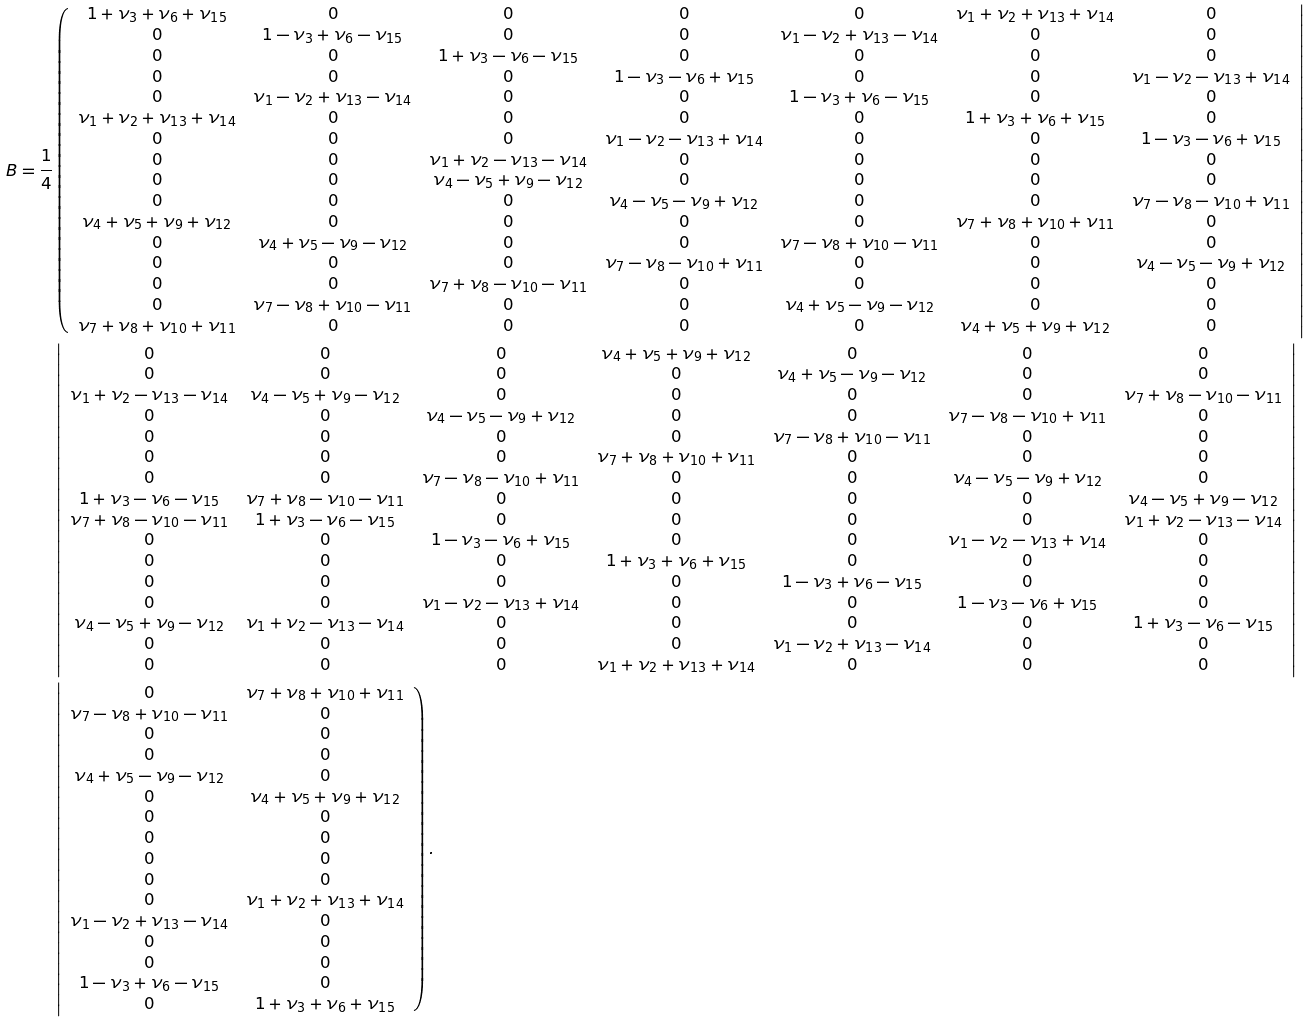<formula> <loc_0><loc_0><loc_500><loc_500>B = \frac { 1 } { 4 } & \left ( \begin{array} { c c c c c c c } 1 + \nu _ { 3 } + \nu _ { 6 } + \nu _ { 1 5 } & 0 & 0 & 0 & 0 & \nu _ { 1 } + \nu _ { 2 } + \nu _ { 1 3 } + \nu _ { 1 4 } & 0 \\ 0 & 1 - \nu _ { 3 } + \nu _ { 6 } - \nu _ { 1 5 } & 0 & 0 & \nu _ { 1 } - \nu _ { 2 } + \nu _ { 1 3 } - \nu _ { 1 4 } & 0 & 0 \\ 0 & 0 & 1 + \nu _ { 3 } - \nu _ { 6 } - \nu _ { 1 5 } & 0 & 0 & 0 & 0 \\ 0 & 0 & 0 & 1 - \nu _ { 3 } - \nu _ { 6 } + \nu _ { 1 5 } & 0 & 0 & \nu _ { 1 } - \nu _ { 2 } - \nu _ { 1 3 } + \nu _ { 1 4 } \\ 0 & \nu _ { 1 } - \nu _ { 2 } + \nu _ { 1 3 } - \nu _ { 1 4 } & 0 & 0 & 1 - \nu _ { 3 } + \nu _ { 6 } - \nu _ { 1 5 } & 0 & 0 \\ \nu _ { 1 } + \nu _ { 2 } + \nu _ { 1 3 } + \nu _ { 1 4 } & 0 & 0 & 0 & 0 & 1 + \nu _ { 3 } + \nu _ { 6 } + \nu _ { 1 5 } & 0 \\ 0 & 0 & 0 & \nu _ { 1 } - \nu _ { 2 } - \nu _ { 1 3 } + \nu _ { 1 4 } & 0 & 0 & 1 - \nu _ { 3 } - \nu _ { 6 } + \nu _ { 1 5 } \\ 0 & 0 & \nu _ { 1 } + \nu _ { 2 } - \nu _ { 1 3 } - \nu _ { 1 4 } & 0 & 0 & 0 & 0 \\ 0 & 0 & \nu _ { 4 } - \nu _ { 5 } + \nu _ { 9 } - \nu _ { 1 2 } & 0 & 0 & 0 & 0 \\ 0 & 0 & 0 & \nu _ { 4 } - \nu _ { 5 } - \nu _ { 9 } + \nu _ { 1 2 } & 0 & 0 & \nu _ { 7 } - \nu _ { 8 } - \nu _ { 1 0 } + \nu _ { 1 1 } \\ \nu _ { 4 } + \nu _ { 5 } + \nu _ { 9 } + \nu _ { 1 2 } & 0 & 0 & 0 & 0 & \nu _ { 7 } + \nu _ { 8 } + \nu _ { 1 0 } + \nu _ { 1 1 } & 0 \\ 0 & \nu _ { 4 } + \nu _ { 5 } - \nu _ { 9 } - \nu _ { 1 2 } & 0 & 0 & \nu _ { 7 } - \nu _ { 8 } + \nu _ { 1 0 } - \nu _ { 1 1 } & 0 & 0 \\ 0 & 0 & 0 & \nu _ { 7 } - \nu _ { 8 } - \nu _ { 1 0 } + \nu _ { 1 1 } & 0 & 0 & \nu _ { 4 } - \nu _ { 5 } - \nu _ { 9 } + \nu _ { 1 2 } \\ 0 & 0 & \nu _ { 7 } + \nu _ { 8 } - \nu _ { 1 0 } - \nu _ { 1 1 } & 0 & 0 & 0 & 0 \\ 0 & \nu _ { 7 } - \nu _ { 8 } + \nu _ { 1 0 } - \nu _ { 1 1 } & 0 & 0 & \nu _ { 4 } + \nu _ { 5 } - \nu _ { 9 } - \nu _ { 1 2 } & 0 & 0 \\ \nu _ { 7 } + \nu _ { 8 } + \nu _ { 1 0 } + \nu _ { 1 1 } & 0 & 0 & 0 & 0 & \nu _ { 4 } + \nu _ { 5 } + \nu _ { 9 } + \nu _ { 1 2 } & 0 \end{array} \right | \\ & \left | \begin{array} { c c c c c c c } 0 & 0 & 0 & \nu _ { 4 } + \nu _ { 5 } + \nu _ { 9 } + \nu _ { 1 2 } & 0 & 0 & 0 \\ 0 & 0 & 0 & 0 & \nu _ { 4 } + \nu _ { 5 } - \nu _ { 9 } - \nu _ { 1 2 } & 0 & 0 \\ \nu _ { 1 } + \nu _ { 2 } - \nu _ { 1 3 } - \nu _ { 1 4 } & \nu _ { 4 } - \nu _ { 5 } + \nu _ { 9 } - \nu _ { 1 2 } & 0 & 0 & 0 & 0 & \nu _ { 7 } + \nu _ { 8 } - \nu _ { 1 0 } - \nu _ { 1 1 } \\ 0 & 0 & \nu _ { 4 } - \nu _ { 5 } - \nu _ { 9 } + \nu _ { 1 2 } & 0 & 0 & \nu _ { 7 } - \nu _ { 8 } - \nu _ { 1 0 } + \nu _ { 1 1 } & 0 \\ 0 & 0 & 0 & 0 & \nu _ { 7 } - \nu _ { 8 } + \nu _ { 1 0 } - \nu _ { 1 1 } & 0 & 0 \\ 0 & 0 & 0 & \nu _ { 7 } + \nu _ { 8 } + \nu _ { 1 0 } + \nu _ { 1 1 } & 0 & 0 & 0 \\ 0 & 0 & \nu _ { 7 } - \nu _ { 8 } - \nu _ { 1 0 } + \nu _ { 1 1 } & 0 & 0 & \nu _ { 4 } - \nu _ { 5 } - \nu _ { 9 } + \nu _ { 1 2 } & 0 \\ 1 + \nu _ { 3 } - \nu _ { 6 } - \nu _ { 1 5 } & \nu _ { 7 } + \nu _ { 8 } - \nu _ { 1 0 } - \nu _ { 1 1 } & 0 & 0 & 0 & 0 & \nu _ { 4 } - \nu _ { 5 } + \nu _ { 9 } - \nu _ { 1 2 } \\ \nu _ { 7 } + \nu _ { 8 } - \nu _ { 1 0 } - \nu _ { 1 1 } & 1 + \nu _ { 3 } - \nu _ { 6 } - \nu _ { 1 5 } & 0 & 0 & 0 & 0 & \nu _ { 1 } + \nu _ { 2 } - \nu _ { 1 3 } - \nu _ { 1 4 } \\ 0 & 0 & 1 - \nu _ { 3 } - \nu _ { 6 } + \nu _ { 1 5 } & 0 & 0 & \nu _ { 1 } - \nu _ { 2 } - \nu _ { 1 3 } + \nu _ { 1 4 } & 0 \\ 0 & 0 & 0 & 1 + \nu _ { 3 } + \nu _ { 6 } + \nu _ { 1 5 } & 0 & 0 & 0 \\ 0 & 0 & 0 & 0 & 1 - \nu _ { 3 } + \nu _ { 6 } - \nu _ { 1 5 } & 0 & 0 \\ 0 & 0 & \nu _ { 1 } - \nu _ { 2 } - \nu _ { 1 3 } + \nu _ { 1 4 } & 0 & 0 & 1 - \nu _ { 3 } - \nu _ { 6 } + \nu _ { 1 5 } & 0 \\ \nu _ { 4 } - \nu _ { 5 } + \nu _ { 9 } - \nu _ { 1 2 } & \nu _ { 1 } + \nu _ { 2 } - \nu _ { 1 3 } - \nu _ { 1 4 } & 0 & 0 & 0 & 0 & 1 + \nu _ { 3 } - \nu _ { 6 } - \nu _ { 1 5 } \\ 0 & 0 & 0 & 0 & \nu _ { 1 } - \nu _ { 2 } + \nu _ { 1 3 } - \nu _ { 1 4 } & 0 & 0 \\ 0 & 0 & 0 & \nu _ { 1 } + \nu _ { 2 } + \nu _ { 1 3 } + \nu _ { 1 4 } & 0 & 0 & 0 \end{array} \right | \\ & \left | \begin{array} { c c } 0 & \nu _ { 7 } + \nu _ { 8 } + \nu _ { 1 0 } + \nu _ { 1 1 } \\ \nu _ { 7 } - \nu _ { 8 } + \nu _ { 1 0 } - \nu _ { 1 1 } & 0 \\ 0 & 0 \\ 0 & 0 \\ \nu _ { 4 } + \nu _ { 5 } - \nu _ { 9 } - \nu _ { 1 2 } & 0 \\ 0 & \nu _ { 4 } + \nu _ { 5 } + \nu _ { 9 } + \nu _ { 1 2 } \\ 0 & 0 \\ 0 & 0 \\ 0 & 0 \\ 0 & 0 \\ 0 & \nu _ { 1 } + \nu _ { 2 } + \nu _ { 1 3 } + \nu _ { 1 4 } \\ \nu _ { 1 } - \nu _ { 2 } + \nu _ { 1 3 } - \nu _ { 1 4 } & 0 \\ 0 & 0 \\ 0 & 0 \\ 1 - \nu _ { 3 } + \nu _ { 6 } - \nu _ { 1 5 } & 0 \\ 0 & 1 + \nu _ { 3 } + \nu _ { 6 } + \nu _ { 1 5 } \end{array} \right ) .</formula> 